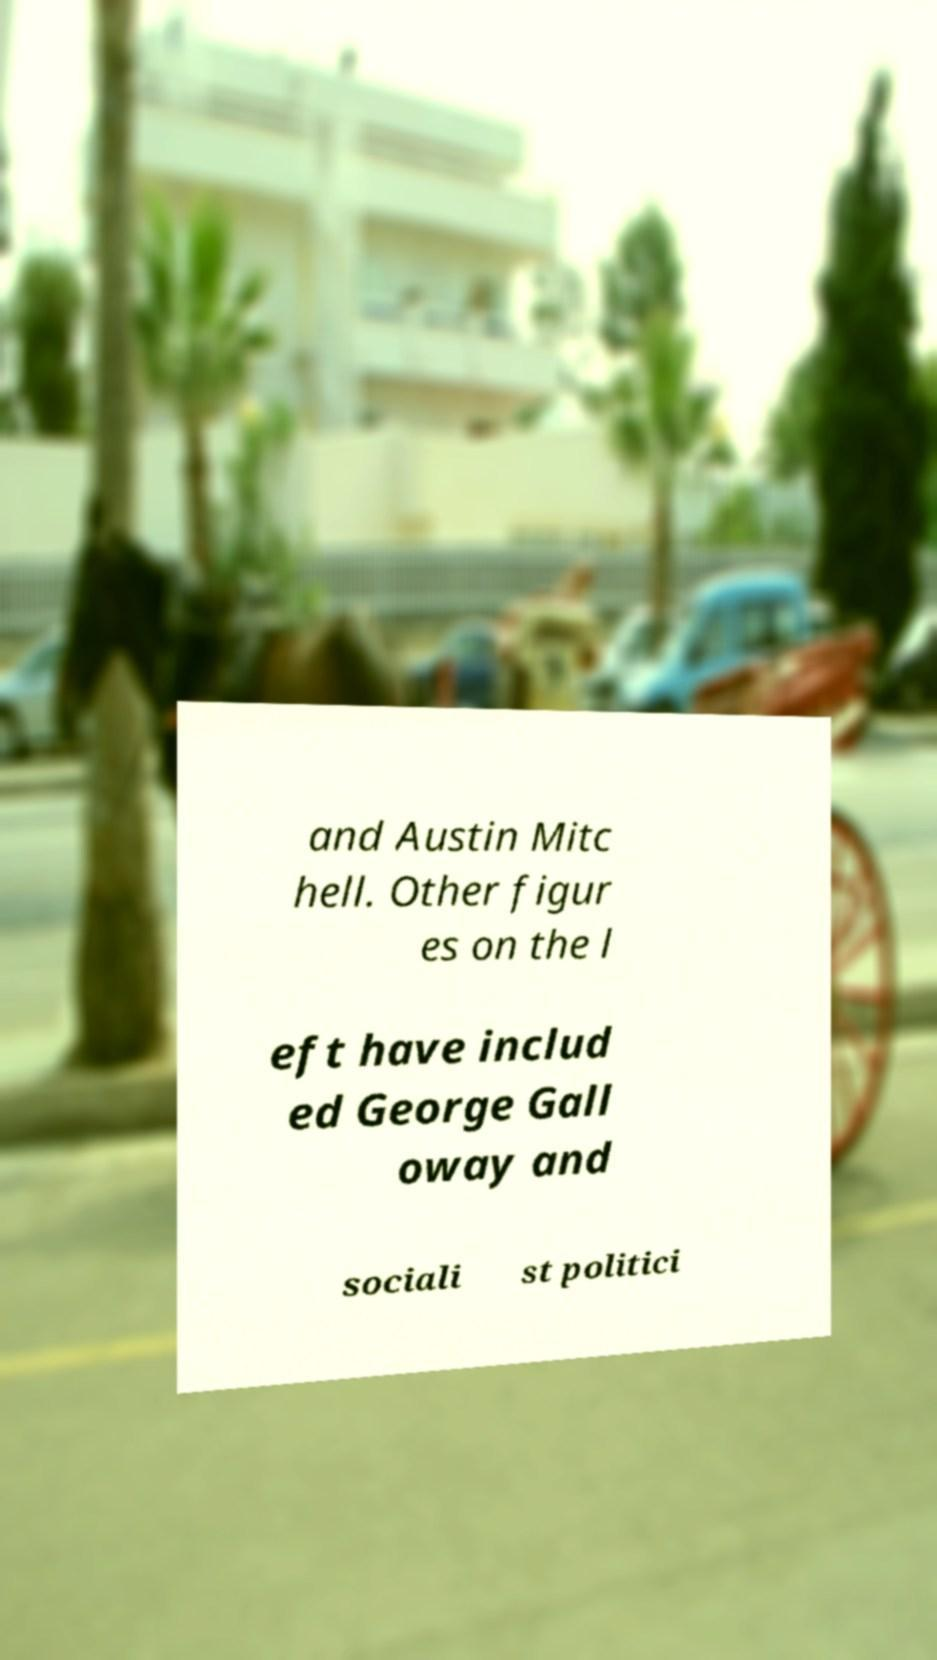Can you accurately transcribe the text from the provided image for me? and Austin Mitc hell. Other figur es on the l eft have includ ed George Gall oway and sociali st politici 